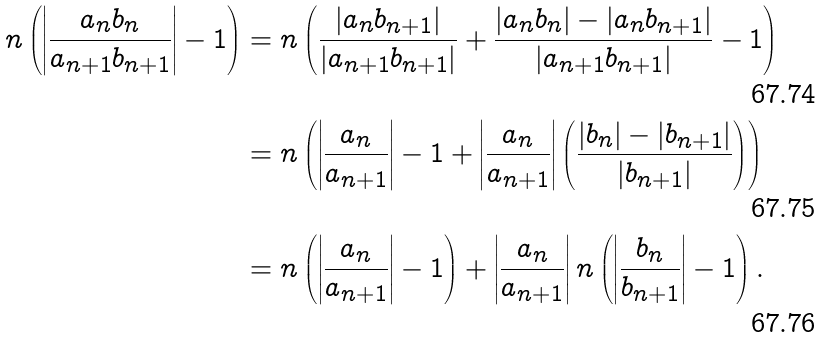<formula> <loc_0><loc_0><loc_500><loc_500>n \left ( \left | \frac { a _ { n } b _ { n } } { a _ { n + 1 } b _ { n + 1 } } \right | - 1 \right ) & = n \left ( \frac { | a _ { n } b _ { n + 1 } | } { | a _ { n + 1 } b _ { n + 1 } | } + \frac { | a _ { n } b _ { n } | - | a _ { n } b _ { n + 1 } | } { | a _ { n + 1 } b _ { n + 1 } | } - 1 \right ) \\ & = n \left ( \left | \frac { a _ { n } } { a _ { n + 1 } } \right | - 1 + \left | \frac { a _ { n } } { a _ { n + 1 } } \right | \left ( \frac { | b _ { n } | - | b _ { n + 1 } | } { | b _ { n + 1 } | } \right ) \right ) \\ & = n \left ( \left | \frac { a _ { n } } { a _ { n + 1 } } \right | - 1 \right ) + \left | \frac { a _ { n } } { a _ { n + 1 } } \right | n \left ( \left | \frac { b _ { n } } { b _ { n + 1 } } \right | - 1 \right ) \text {.}</formula> 